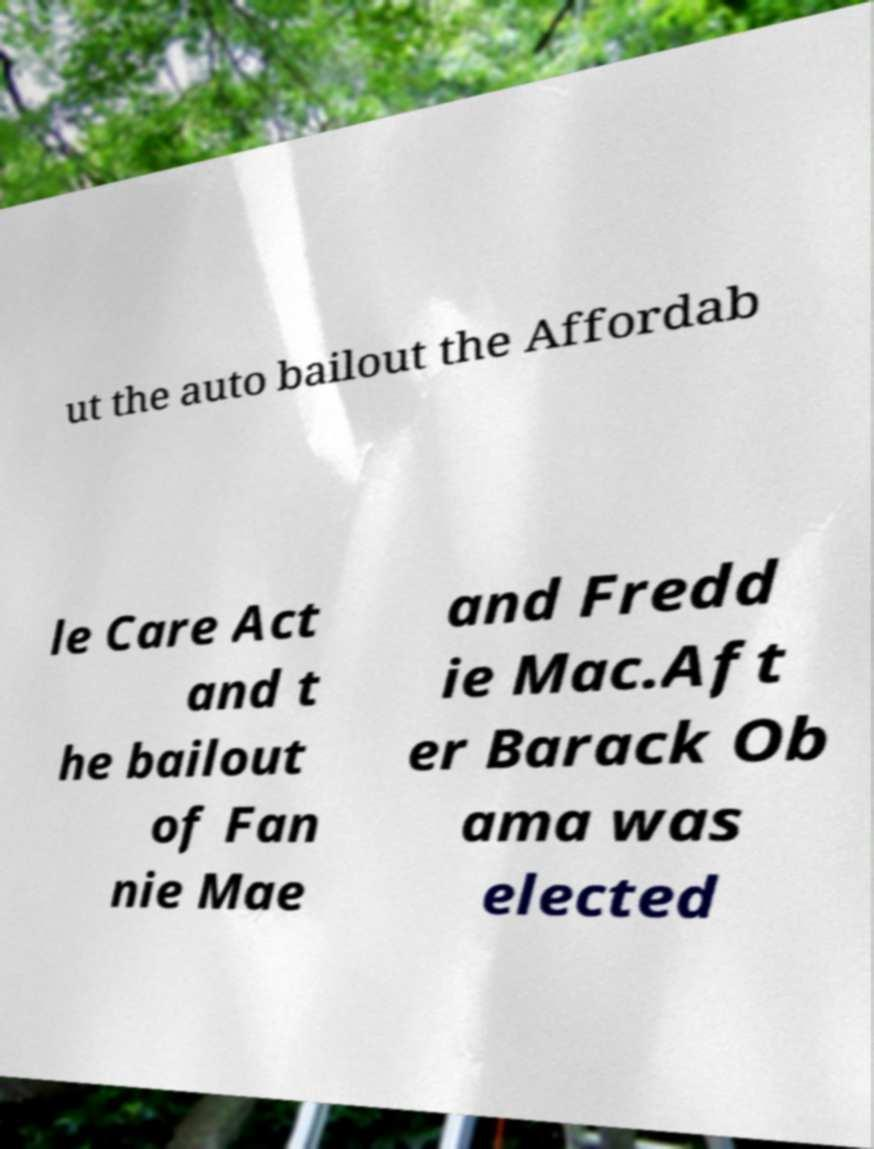Can you read and provide the text displayed in the image?This photo seems to have some interesting text. Can you extract and type it out for me? ut the auto bailout the Affordab le Care Act and t he bailout of Fan nie Mae and Fredd ie Mac.Aft er Barack Ob ama was elected 